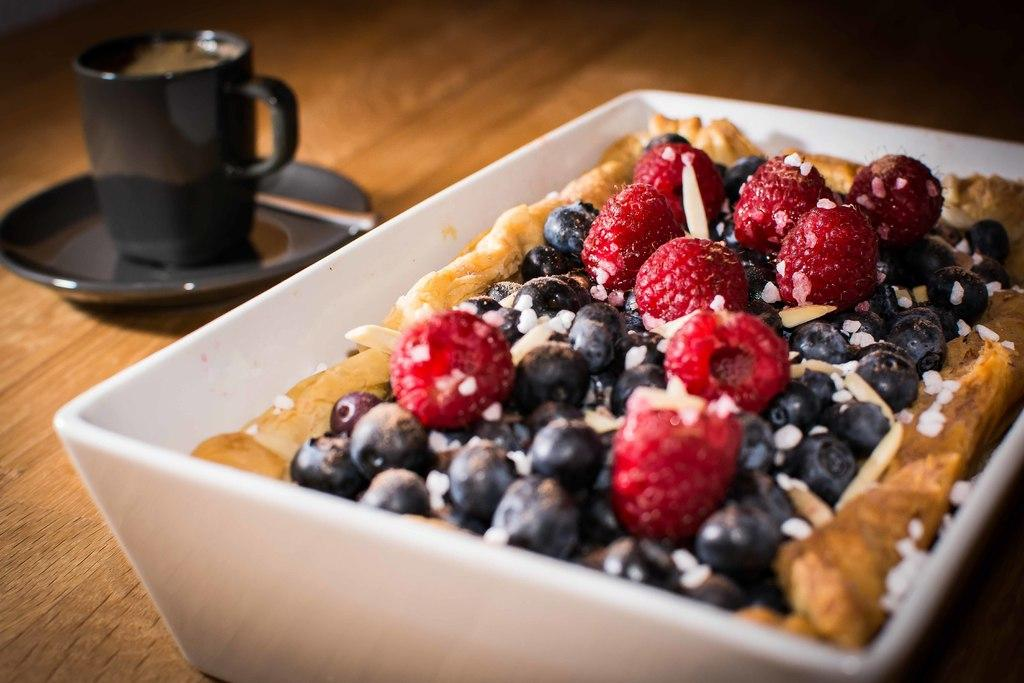What is in the bowl that is visible in the image? There are food items in a bowl in the image. Where is the bowl located in the image? The bowl is on a table. What other items can be seen on the table in the image? There is a cup and saucer on the left side of the image. What type of magic is being performed with the honey in the image? There is no honey present in the image, and therefore no magic can be observed. 